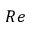Convert formula to latex. <formula><loc_0><loc_0><loc_500><loc_500>R e</formula> 